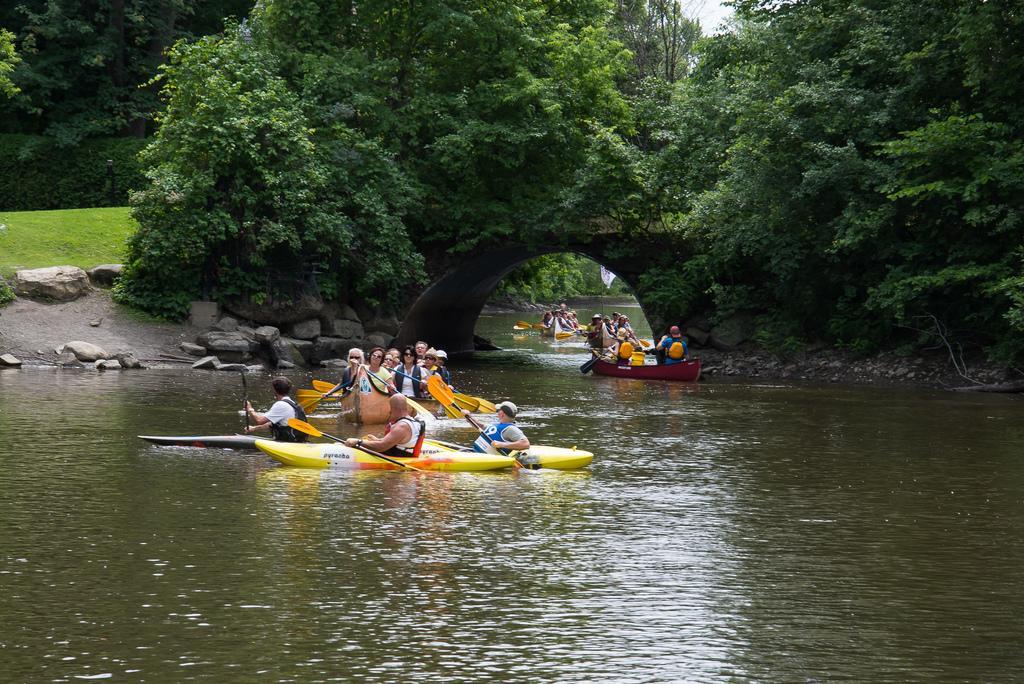How would you summarize this image in a sentence or two? In this image in the center there are persons surf boating on the water. There are trees on the top and in the background there's grass on the ground and there are trees. 